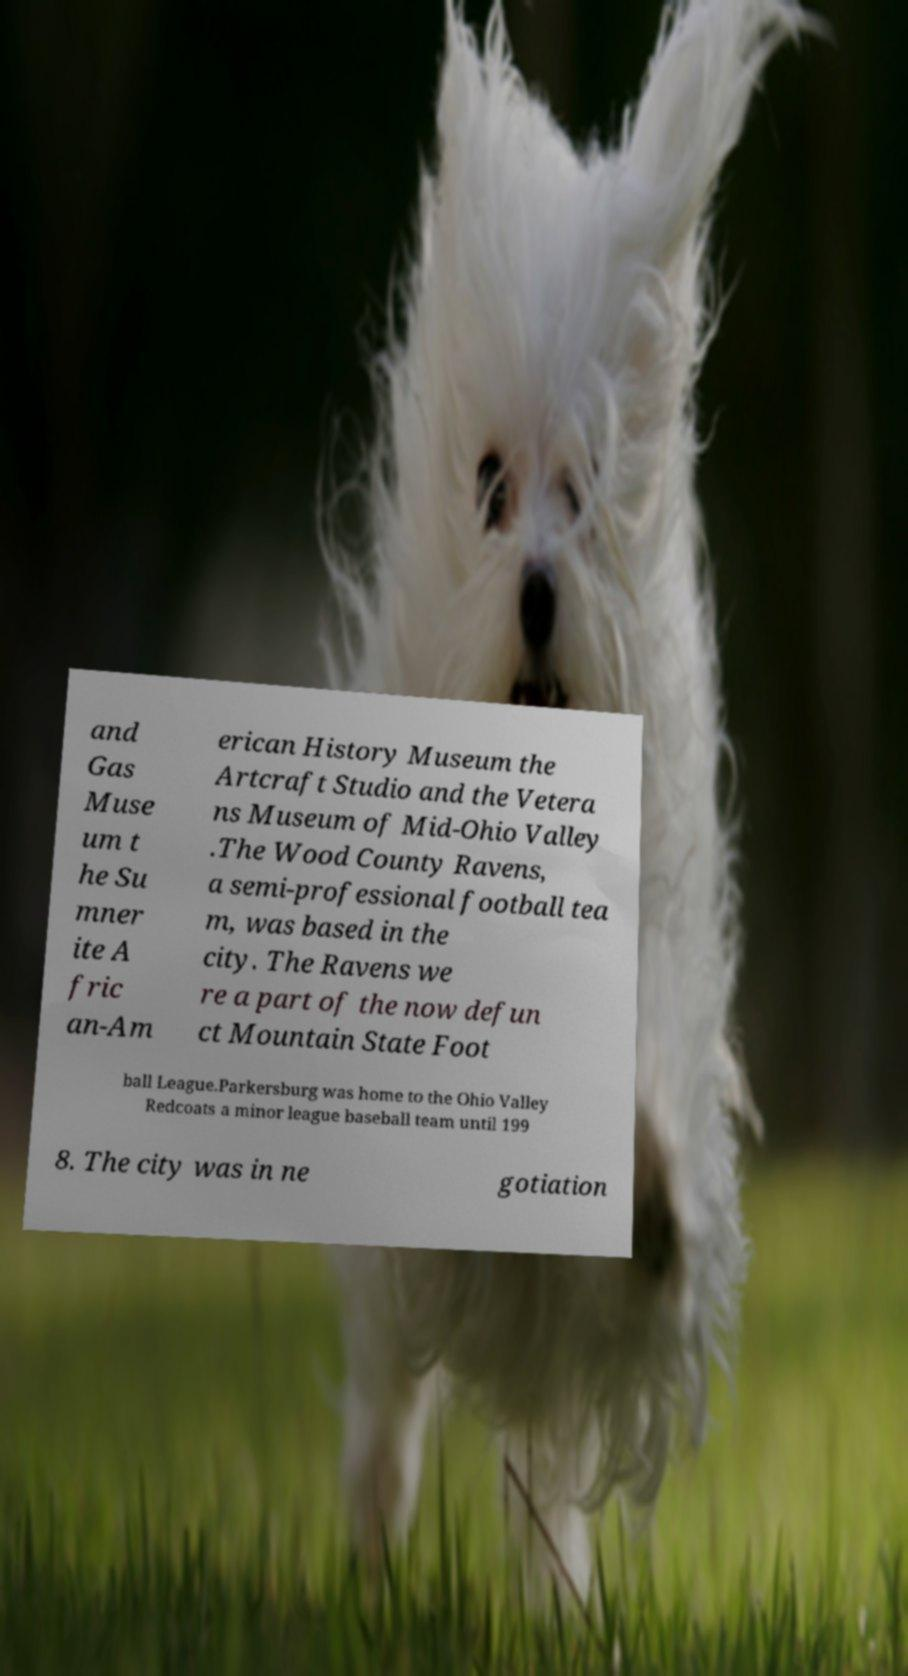There's text embedded in this image that I need extracted. Can you transcribe it verbatim? and Gas Muse um t he Su mner ite A fric an-Am erican History Museum the Artcraft Studio and the Vetera ns Museum of Mid-Ohio Valley .The Wood County Ravens, a semi-professional football tea m, was based in the city. The Ravens we re a part of the now defun ct Mountain State Foot ball League.Parkersburg was home to the Ohio Valley Redcoats a minor league baseball team until 199 8. The city was in ne gotiation 